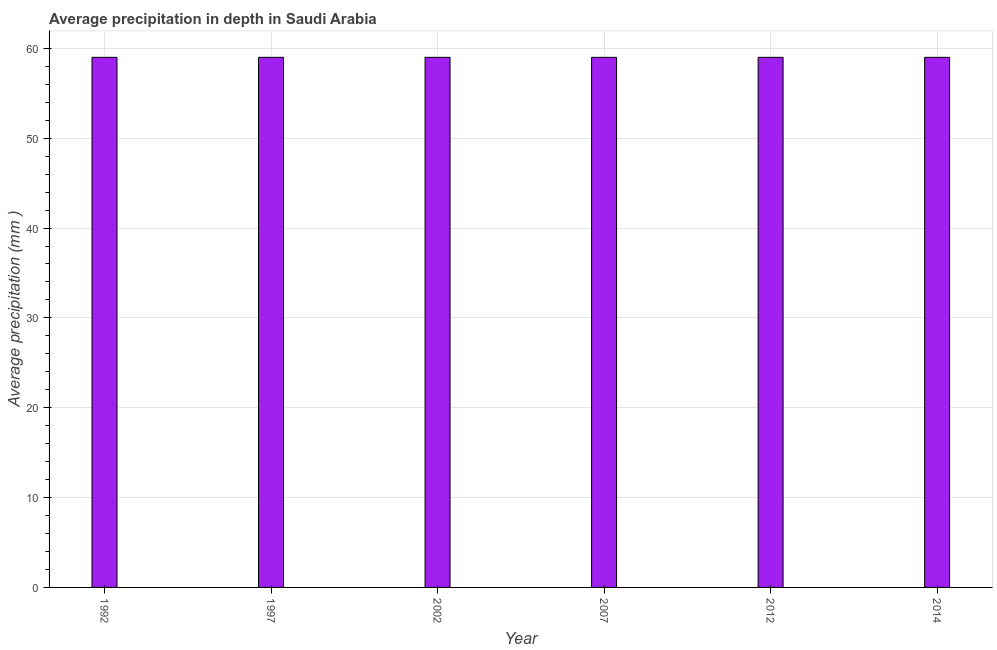What is the title of the graph?
Offer a terse response. Average precipitation in depth in Saudi Arabia. What is the label or title of the Y-axis?
Provide a short and direct response. Average precipitation (mm ). Across all years, what is the maximum average precipitation in depth?
Offer a very short reply. 59. Across all years, what is the minimum average precipitation in depth?
Your answer should be very brief. 59. In which year was the average precipitation in depth minimum?
Provide a short and direct response. 1992. What is the sum of the average precipitation in depth?
Make the answer very short. 354. What is the difference between the average precipitation in depth in 2012 and 2014?
Provide a succinct answer. 0. What is the median average precipitation in depth?
Your answer should be very brief. 59. In how many years, is the average precipitation in depth greater than 8 mm?
Make the answer very short. 6. Is the average precipitation in depth in 1997 less than that in 2012?
Give a very brief answer. No. Is the sum of the average precipitation in depth in 2007 and 2014 greater than the maximum average precipitation in depth across all years?
Provide a short and direct response. Yes. What is the difference between the highest and the lowest average precipitation in depth?
Your answer should be very brief. 0. How many bars are there?
Provide a short and direct response. 6. Are all the bars in the graph horizontal?
Offer a terse response. No. What is the Average precipitation (mm ) in 1992?
Offer a terse response. 59. What is the difference between the Average precipitation (mm ) in 1992 and 1997?
Give a very brief answer. 0. What is the difference between the Average precipitation (mm ) in 1992 and 2002?
Offer a very short reply. 0. What is the difference between the Average precipitation (mm ) in 1992 and 2007?
Offer a terse response. 0. What is the difference between the Average precipitation (mm ) in 1992 and 2014?
Offer a very short reply. 0. What is the difference between the Average precipitation (mm ) in 1997 and 2007?
Your answer should be compact. 0. What is the difference between the Average precipitation (mm ) in 1997 and 2012?
Your answer should be compact. 0. What is the difference between the Average precipitation (mm ) in 1997 and 2014?
Offer a terse response. 0. What is the difference between the Average precipitation (mm ) in 2002 and 2012?
Provide a succinct answer. 0. What is the difference between the Average precipitation (mm ) in 2002 and 2014?
Make the answer very short. 0. What is the difference between the Average precipitation (mm ) in 2007 and 2012?
Provide a short and direct response. 0. What is the difference between the Average precipitation (mm ) in 2007 and 2014?
Offer a terse response. 0. What is the difference between the Average precipitation (mm ) in 2012 and 2014?
Your answer should be compact. 0. What is the ratio of the Average precipitation (mm ) in 1992 to that in 2012?
Make the answer very short. 1. What is the ratio of the Average precipitation (mm ) in 1992 to that in 2014?
Your response must be concise. 1. What is the ratio of the Average precipitation (mm ) in 1997 to that in 2002?
Provide a succinct answer. 1. What is the ratio of the Average precipitation (mm ) in 2002 to that in 2007?
Make the answer very short. 1. What is the ratio of the Average precipitation (mm ) in 2012 to that in 2014?
Ensure brevity in your answer.  1. 